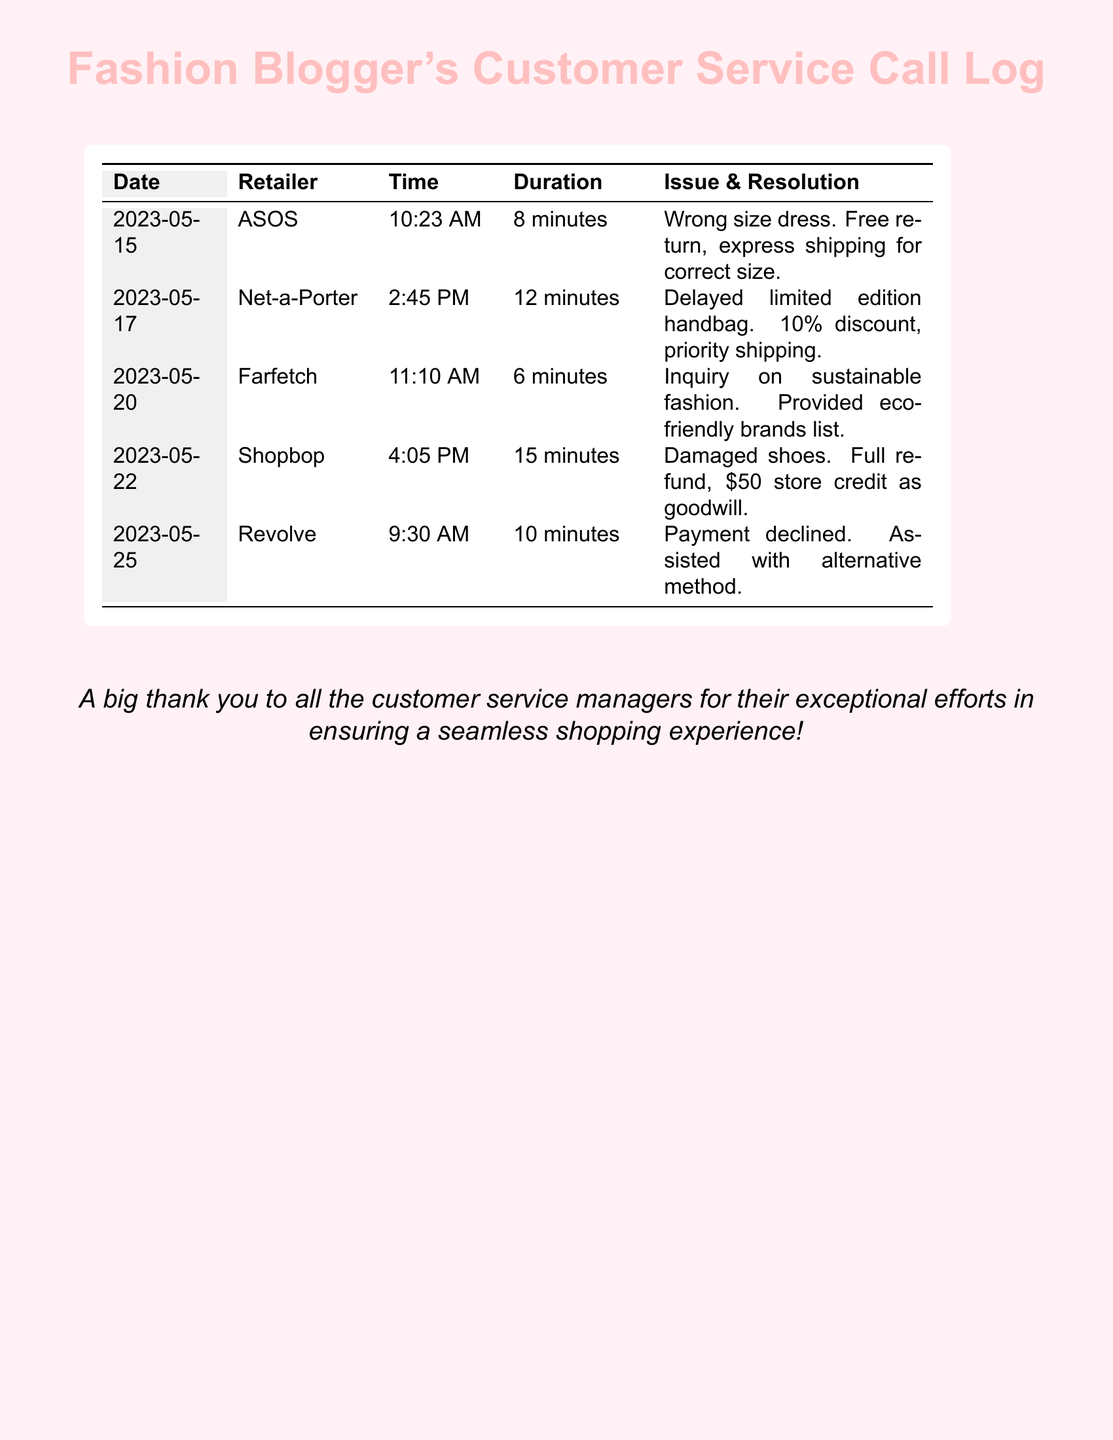What date did the call about the damaged shoes happen? The call about the damaged shoes took place on May 22, 2023, as shown in the table.
Answer: May 22, 2023 How long was the call regarding the delayed handbag? The duration of the call regarding the delayed handbag is recorded as 12 minutes in the document.
Answer: 12 minutes What retailer was contacted for the issue with the wrong size dress? The document specifies ASOS as the retailer contacted for the wrong size dress issue.
Answer: ASOS What was the resolution offered for the payment decline issue? The resolution for the payment decline issue involved assistance with an alternative payment method, as stated in the document.
Answer: Assisted with alternative method How much store credit was provided for the damaged shoes? The document mentions a $50 store credit was issued as goodwill in the case of the damaged shoes.
Answer: $50 Which retailer provided a list of eco-friendly brands? The retailer Farfetch provided a list of eco-friendly brands during the inquiry on sustainable fashion.
Answer: Farfetch What discount was given for the delayed limited edition handbag? The document records a 10% discount being offered for the delayed limited edition handbag.
Answer: 10% What was the duration of the call about the inquiry on sustainable fashion? The duration of the call about the inquiry on sustainable fashion is indicated to be 6 minutes.
Answer: 6 minutes What type of issue was resolved on May 20, 2023? The issue resolved on May 20, 2023, was an inquiry on sustainable fashion according to the records.
Answer: Inquiry on sustainable fashion 